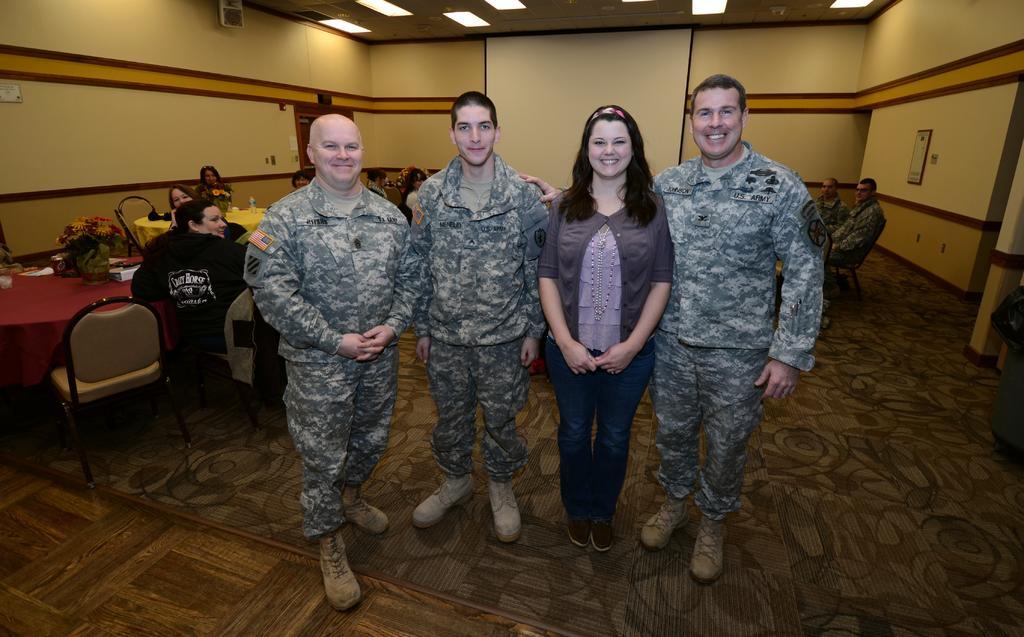Can you describe this image briefly? In the center of the image we can see a lady standing and smiling and there are men wearing uniforms. In the background there are tables and we can see people sitting. There are chairs and we can see decors and some objects placed on the tables. In the background there is a wall. At the top there are lights. 